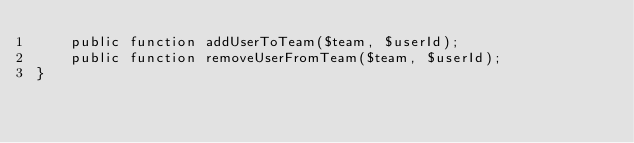Convert code to text. <code><loc_0><loc_0><loc_500><loc_500><_PHP_>    public function addUserToTeam($team, $userId);
    public function removeUserFromTeam($team, $userId);
}
</code> 